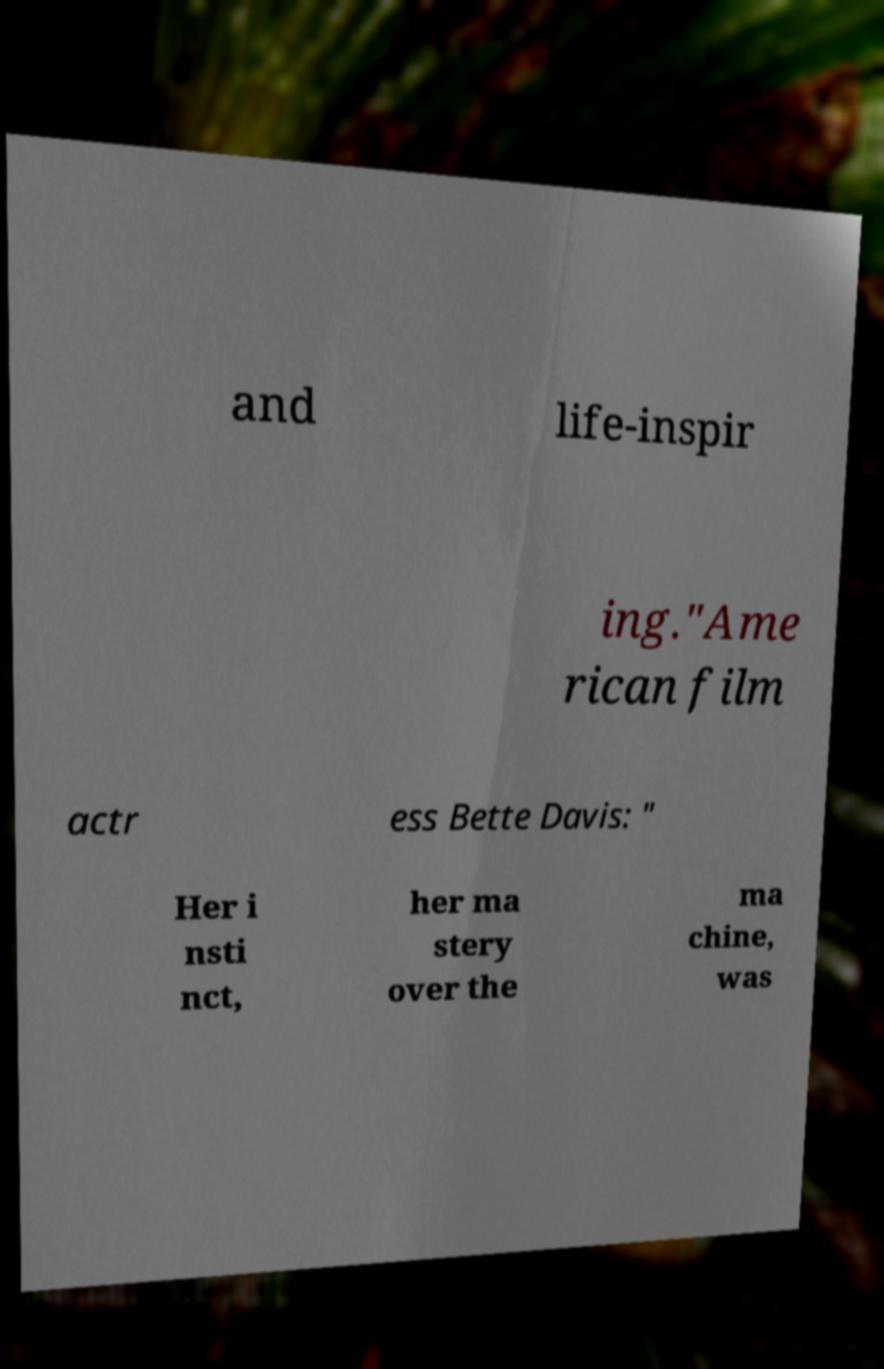For documentation purposes, I need the text within this image transcribed. Could you provide that? and life-inspir ing."Ame rican film actr ess Bette Davis: " Her i nsti nct, her ma stery over the ma chine, was 